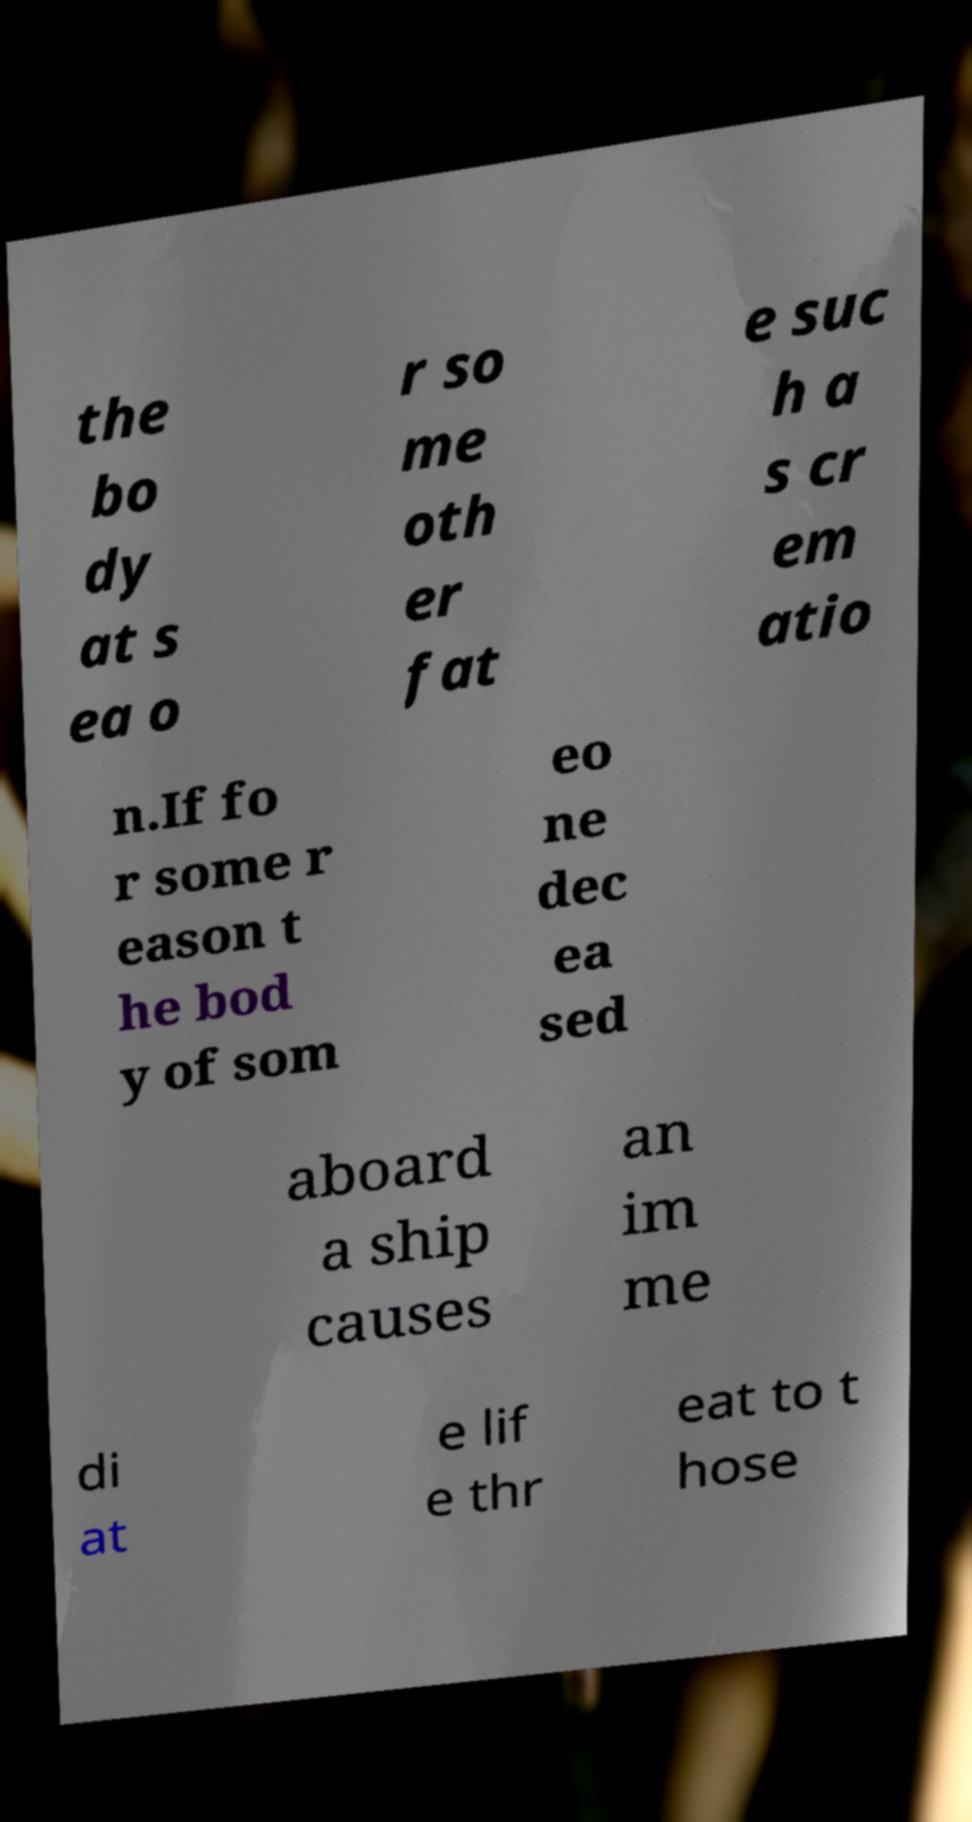For documentation purposes, I need the text within this image transcribed. Could you provide that? the bo dy at s ea o r so me oth er fat e suc h a s cr em atio n.If fo r some r eason t he bod y of som eo ne dec ea sed aboard a ship causes an im me di at e lif e thr eat to t hose 